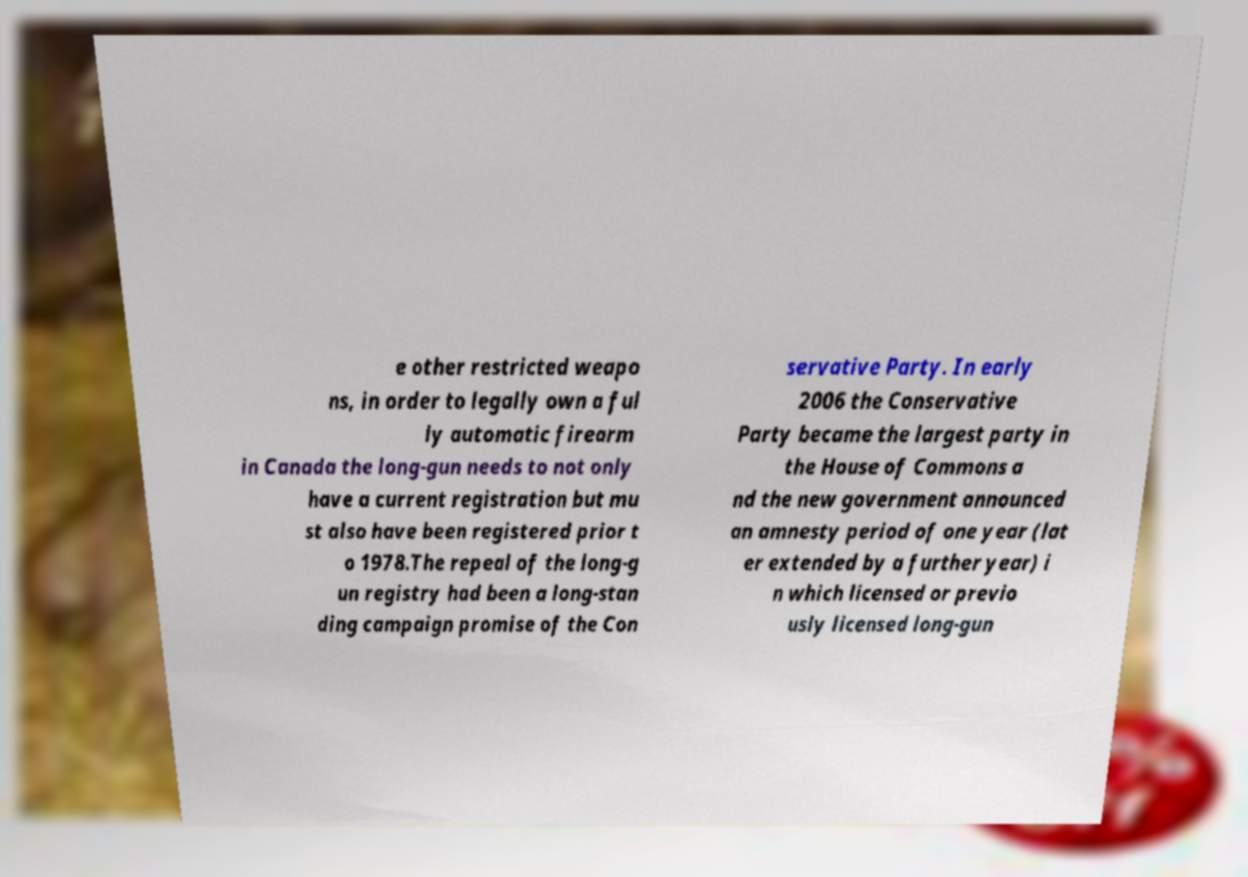Can you accurately transcribe the text from the provided image for me? e other restricted weapo ns, in order to legally own a ful ly automatic firearm in Canada the long-gun needs to not only have a current registration but mu st also have been registered prior t o 1978.The repeal of the long-g un registry had been a long-stan ding campaign promise of the Con servative Party. In early 2006 the Conservative Party became the largest party in the House of Commons a nd the new government announced an amnesty period of one year (lat er extended by a further year) i n which licensed or previo usly licensed long-gun 